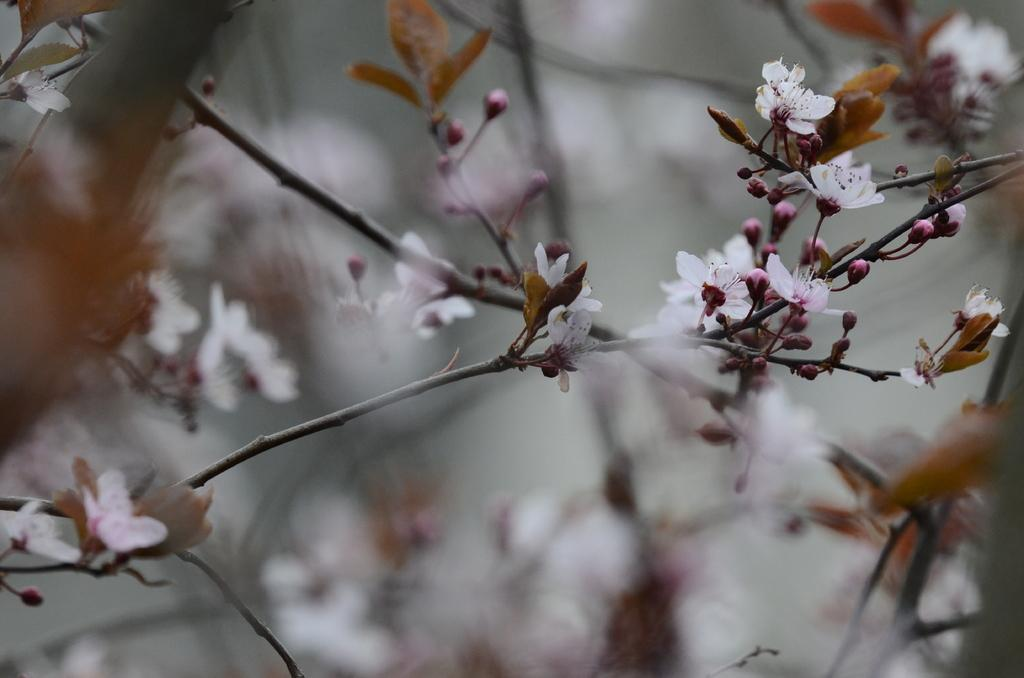What type of plant structures can be seen in the image? There are stems of trees in the image. What are some features of the stems? The stems have flowers, leaves, and buds visible on them. What type of station is depicted in the image? There is no station present in the image; it features stems of trees with flowers, leaves, and buds. Can you tell me which dad is mentioned in the image? There is no mention of a dad or any person in the image; it focuses on the stems of trees and their features. 